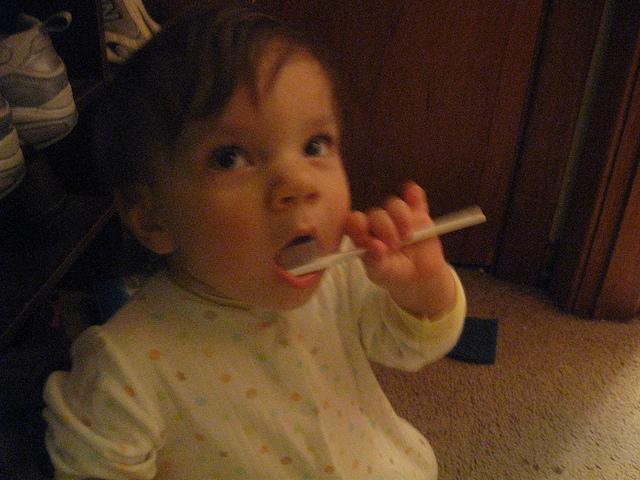How many toothbrushes can you see?
Give a very brief answer. 1. 